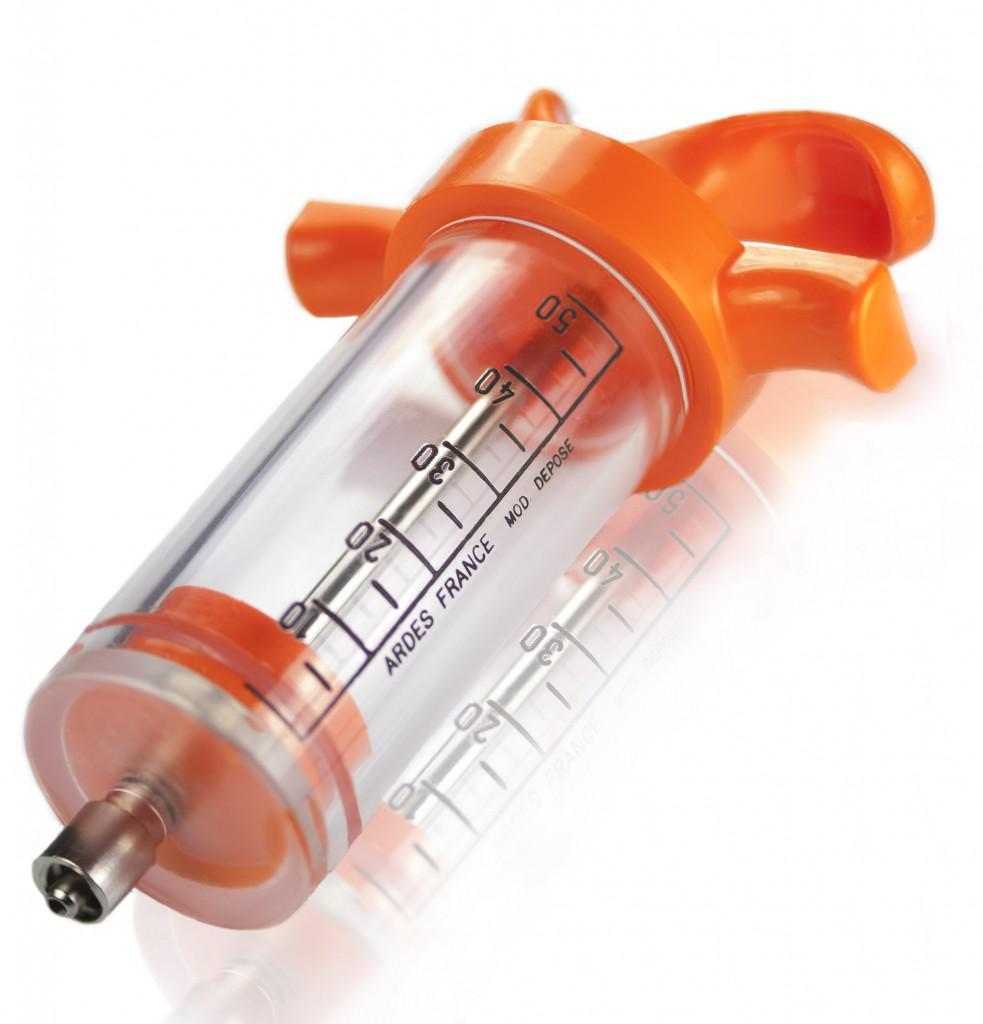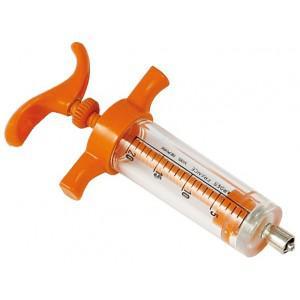The first image is the image on the left, the second image is the image on the right. Evaluate the accuracy of this statement regarding the images: "Each of the syringes has an orange plunger.". Is it true? Answer yes or no. Yes. The first image is the image on the left, the second image is the image on the right. For the images shown, is this caption "There are two orange colored syringes." true? Answer yes or no. Yes. 